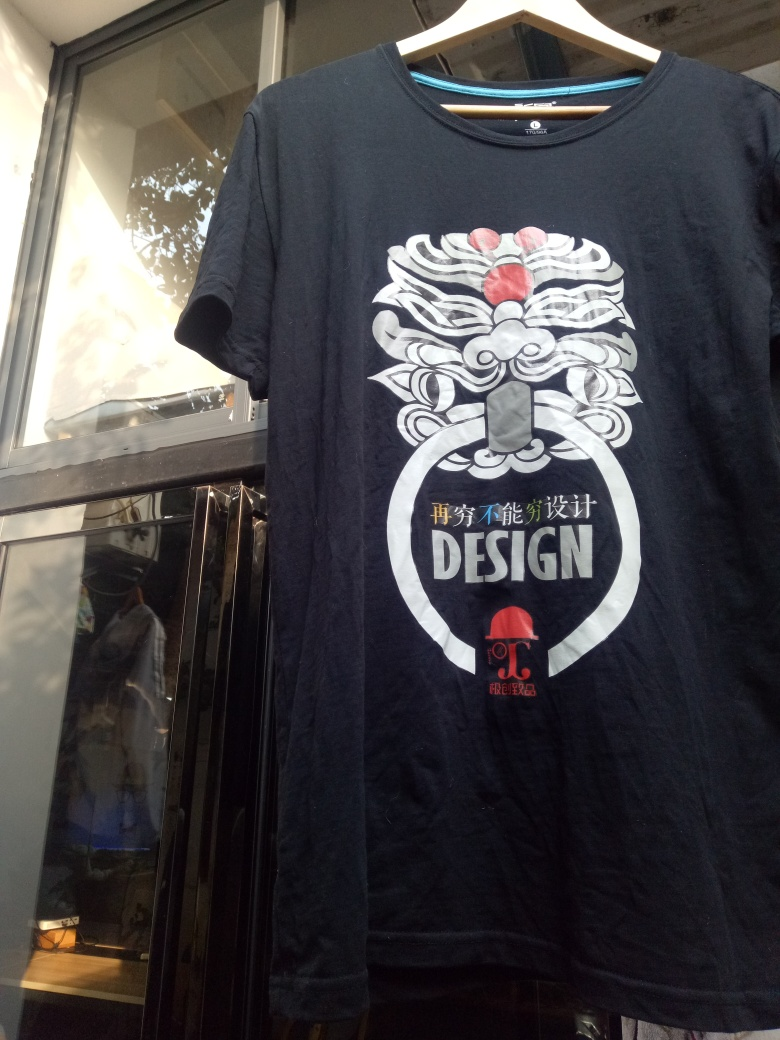What mood does the T-shirt design evoke? The T-shirt design portrays a sense of boldness and cultural heritage, possibly evoking feelings of empowerment or mystique. The use of strong contrasting colors, such as the dominantly white design on a dark fabric, along with the traditional motif, could suggest elements of strength, history, and artistic expression. 